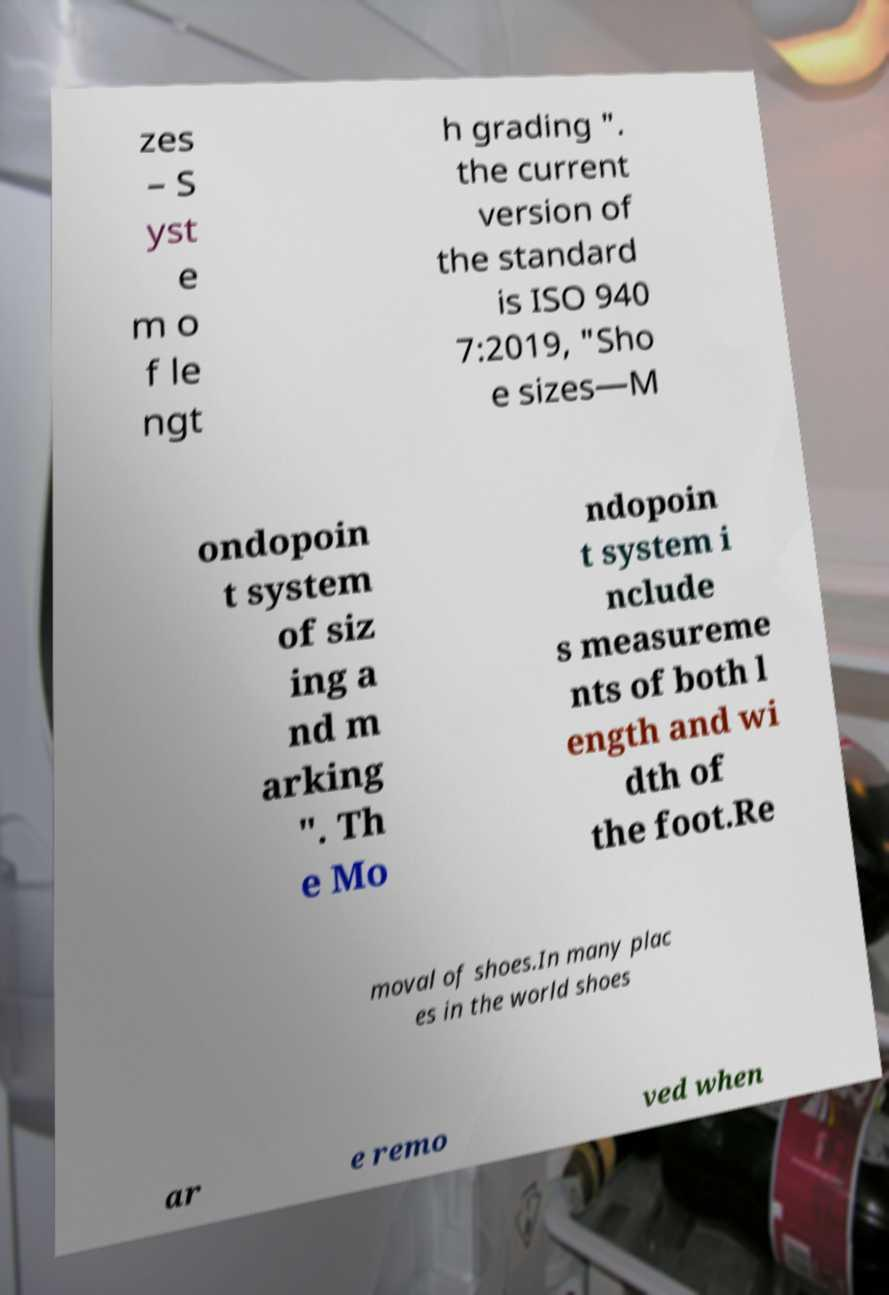For documentation purposes, I need the text within this image transcribed. Could you provide that? zes – S yst e m o f le ngt h grading ". the current version of the standard is ISO 940 7:2019, "Sho e sizes—M ondopoin t system of siz ing a nd m arking ". Th e Mo ndopoin t system i nclude s measureme nts of both l ength and wi dth of the foot.Re moval of shoes.In many plac es in the world shoes ar e remo ved when 